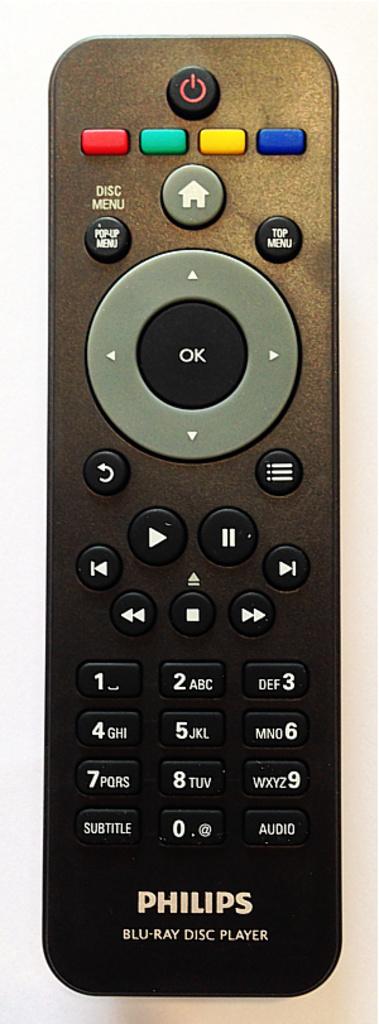What brand is the remote?
Keep it short and to the point. Philips. What does it say on the big black button in the middle?
Your answer should be compact. Ok. 